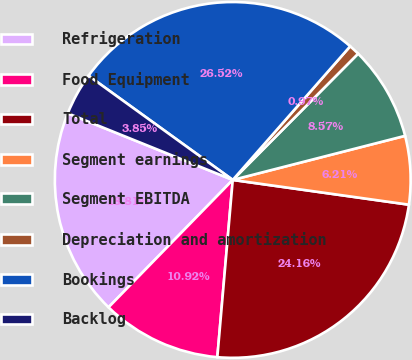Convert chart to OTSL. <chart><loc_0><loc_0><loc_500><loc_500><pie_chart><fcel>Refrigeration<fcel>Food Equipment<fcel>Total<fcel>Segment earnings<fcel>Segment EBITDA<fcel>Depreciation and amortization<fcel>Bookings<fcel>Backlog<nl><fcel>18.81%<fcel>10.92%<fcel>24.16%<fcel>6.21%<fcel>8.57%<fcel>0.97%<fcel>26.52%<fcel>3.85%<nl></chart> 